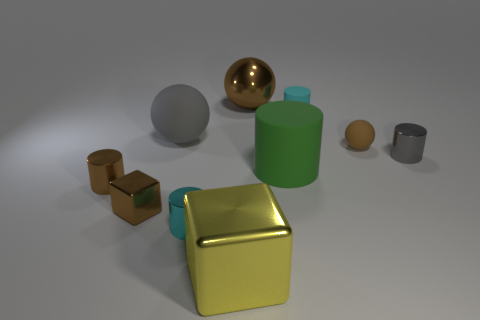Subtract all balls. How many objects are left? 7 Add 9 small gray cylinders. How many small gray cylinders are left? 10 Add 9 small gray metal balls. How many small gray metal balls exist? 9 Subtract 0 green spheres. How many objects are left? 10 Subtract all tiny cylinders. Subtract all gray spheres. How many objects are left? 5 